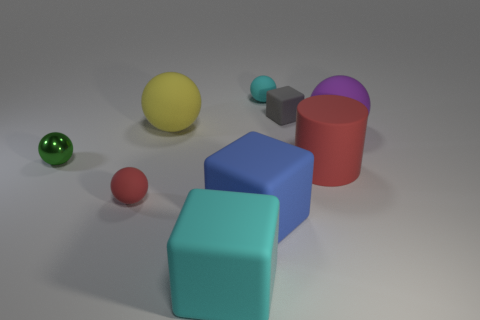Add 1 green balls. How many objects exist? 10 Subtract all large yellow matte balls. How many balls are left? 4 Subtract all red balls. How many balls are left? 4 Subtract all blocks. How many objects are left? 6 Subtract all red cylinders. How many blue cubes are left? 1 Subtract all small gray objects. Subtract all small red objects. How many objects are left? 7 Add 9 red matte cylinders. How many red matte cylinders are left? 10 Add 9 small gray metal spheres. How many small gray metal spheres exist? 9 Subtract 0 purple cylinders. How many objects are left? 9 Subtract 1 cylinders. How many cylinders are left? 0 